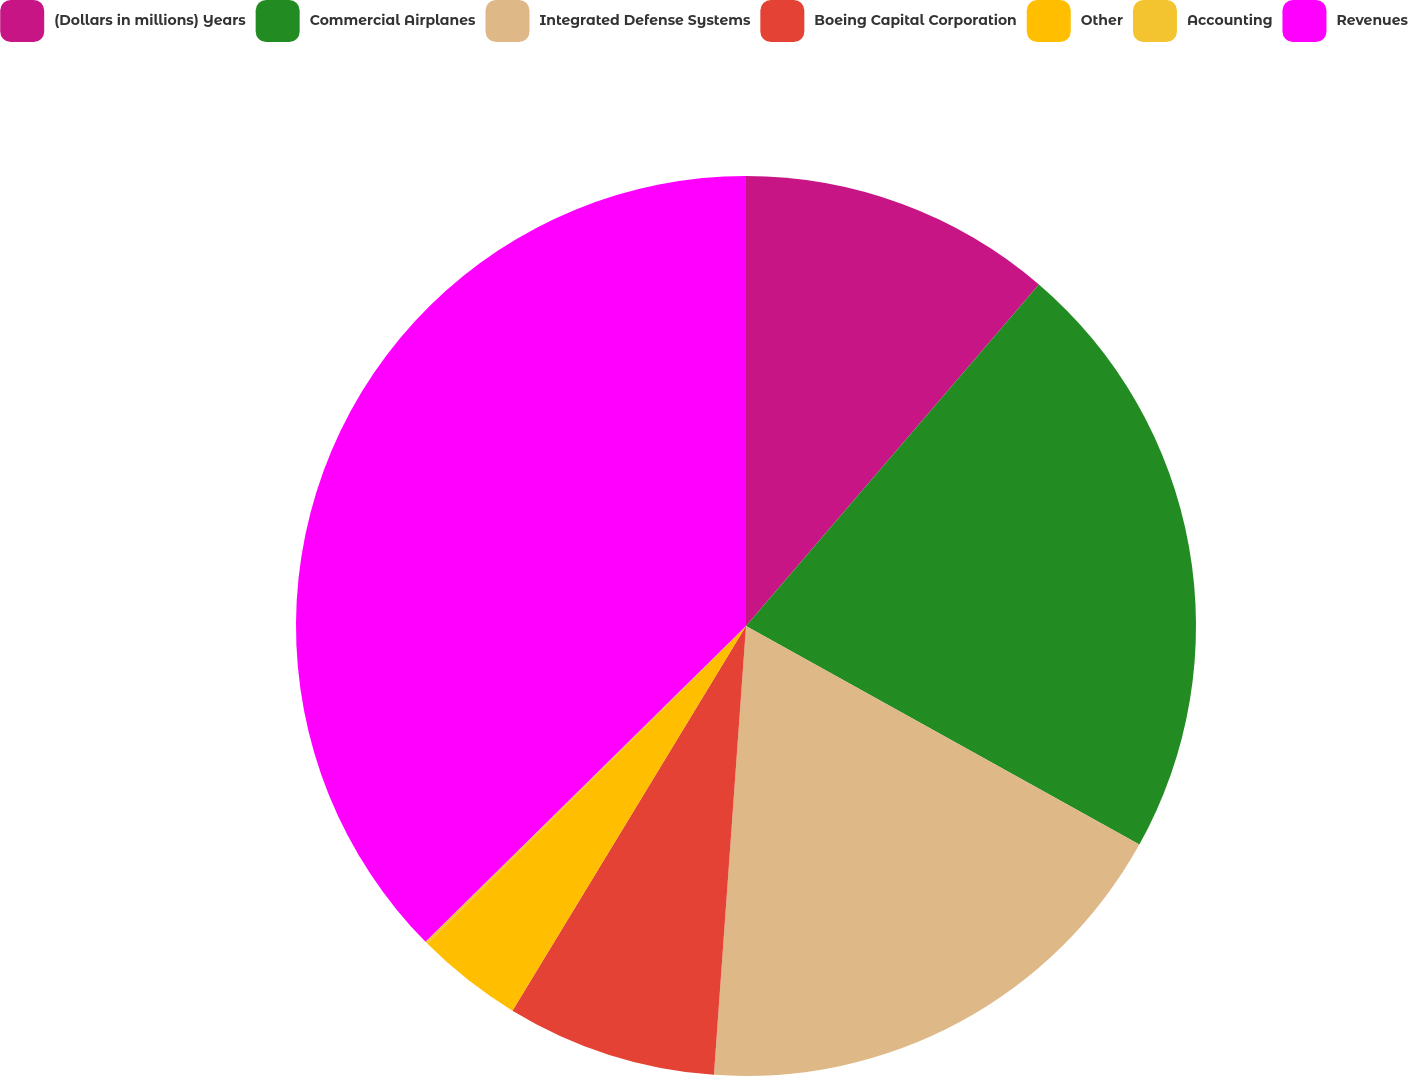<chart> <loc_0><loc_0><loc_500><loc_500><pie_chart><fcel>(Dollars in millions) Years<fcel>Commercial Airplanes<fcel>Integrated Defense Systems<fcel>Boeing Capital Corporation<fcel>Other<fcel>Accounting<fcel>Revenues<nl><fcel>11.28%<fcel>21.79%<fcel>18.06%<fcel>7.55%<fcel>3.83%<fcel>0.1%<fcel>37.38%<nl></chart> 